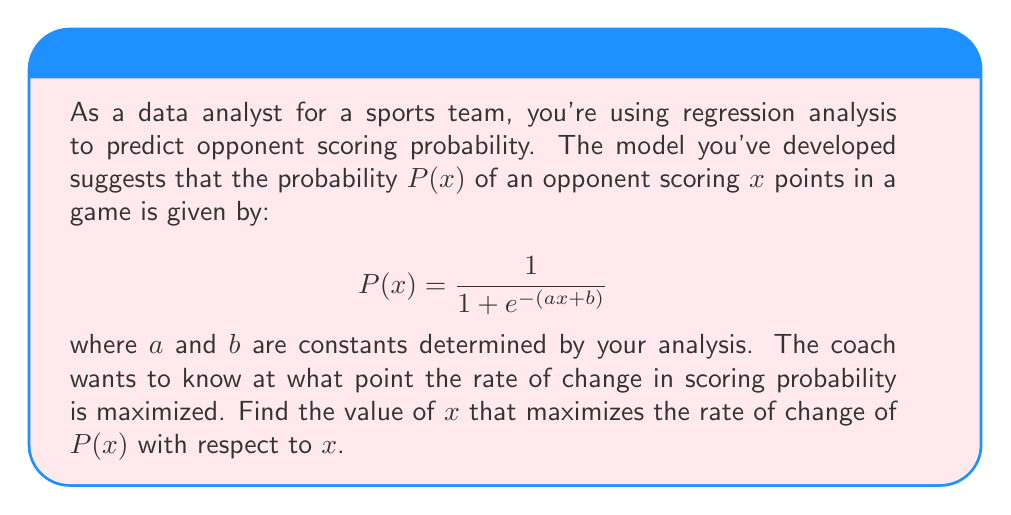Could you help me with this problem? To solve this problem, we need to follow these steps:

1) First, we need to find the derivative of $P(x)$ with respect to $x$. This will give us the rate of change of the probability.

2) Then, we need to find the second derivative and set it to zero to find the point where the rate of change is maximized.

Step 1: Finding the first derivative

Let's use the chain rule to differentiate $P(x)$:

$$\frac{dP}{dx} = \frac{d}{dx}\left(\frac{1}{1 + e^{-(ax + b)}}\right) = \frac{ae^{-(ax + b)}}{(1 + e^{-(ax + b)})^2}$$

We can simplify this by substituting $P(x)$ back in:

$$\frac{dP}{dx} = aP(x)(1 - P(x))$$

Step 2: Finding the second derivative

Now let's differentiate again:

$$\begin{align}
\frac{d^2P}{dx^2} &= a\frac{d}{dx}[P(x)(1 - P(x))] \\
&= a[\frac{dP}{dx}(1 - P(x)) + P(x)(-\frac{dP}{dx})] \\
&= a[aP(x)(1 - P(x))(1 - P(x)) - aP(x)^2(1 - P(x))] \\
&= a^2P(x)(1 - P(x))(1 - 2P(x))
\end{align}$$

Step 3: Setting the second derivative to zero

For the rate of change to be maximized, we set this equal to zero:

$$a^2P(x)(1 - P(x))(1 - 2P(x)) = 0$$

The only factor that can be zero (given that $a \neq 0$ and $0 < P(x) < 1$) is:

$$1 - 2P(x) = 0$$

Solving this:

$$P(x) = \frac{1}{2}$$

Step 4: Solving for x

Now we can solve for $x$ using the original equation:

$$\frac{1}{2} = \frac{1}{1 + e^{-(ax + b)}}$$

$$1 + e^{-(ax + b)} = 2$$

$$e^{-(ax + b)} = 1$$

$$-(ax + b) = 0$$

$$x = -\frac{b}{a}$$

Therefore, the rate of change of the probability is maximized when $x = -\frac{b}{a}$.
Answer: The value of $x$ that maximizes the rate of change of $P(x)$ is $x = -\frac{b}{a}$. 